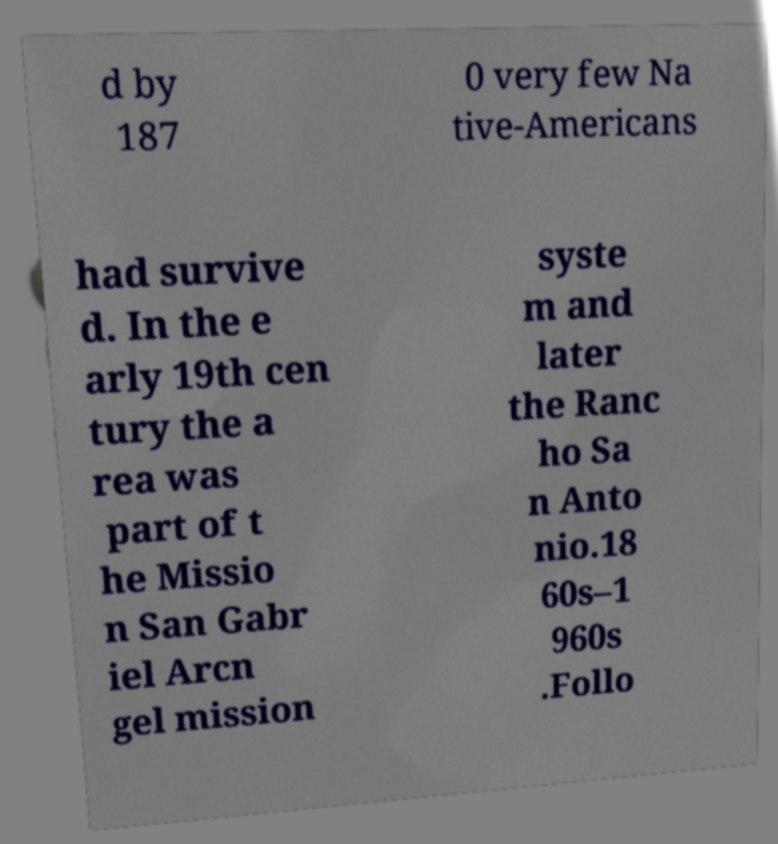Can you read and provide the text displayed in the image?This photo seems to have some interesting text. Can you extract and type it out for me? d by 187 0 very few Na tive-Americans had survive d. In the e arly 19th cen tury the a rea was part of t he Missio n San Gabr iel Arcn gel mission syste m and later the Ranc ho Sa n Anto nio.18 60s–1 960s .Follo 